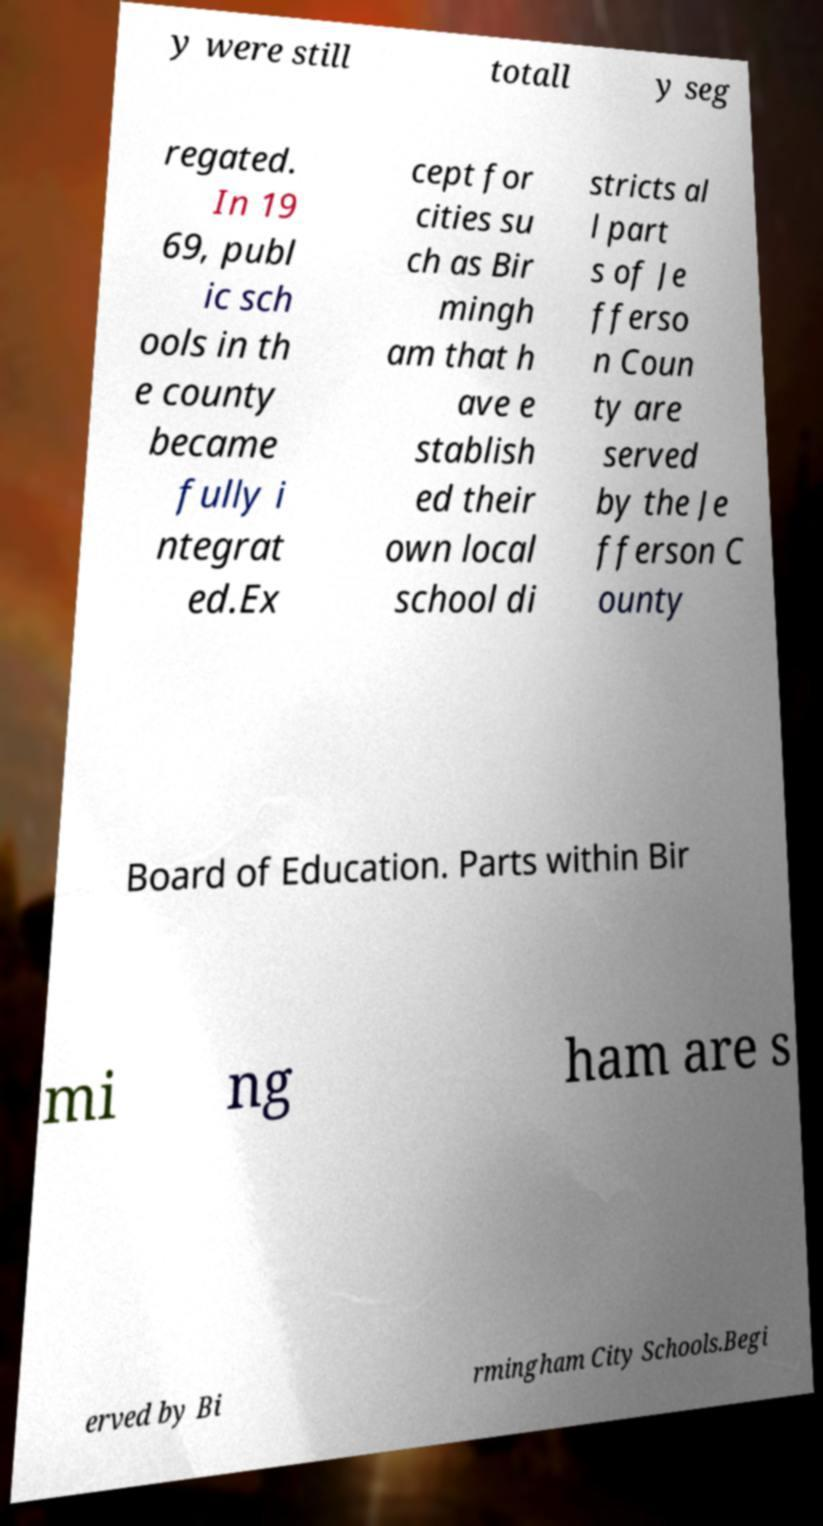I need the written content from this picture converted into text. Can you do that? y were still totall y seg regated. In 19 69, publ ic sch ools in th e county became fully i ntegrat ed.Ex cept for cities su ch as Bir mingh am that h ave e stablish ed their own local school di stricts al l part s of Je fferso n Coun ty are served by the Je fferson C ounty Board of Education. Parts within Bir mi ng ham are s erved by Bi rmingham City Schools.Begi 